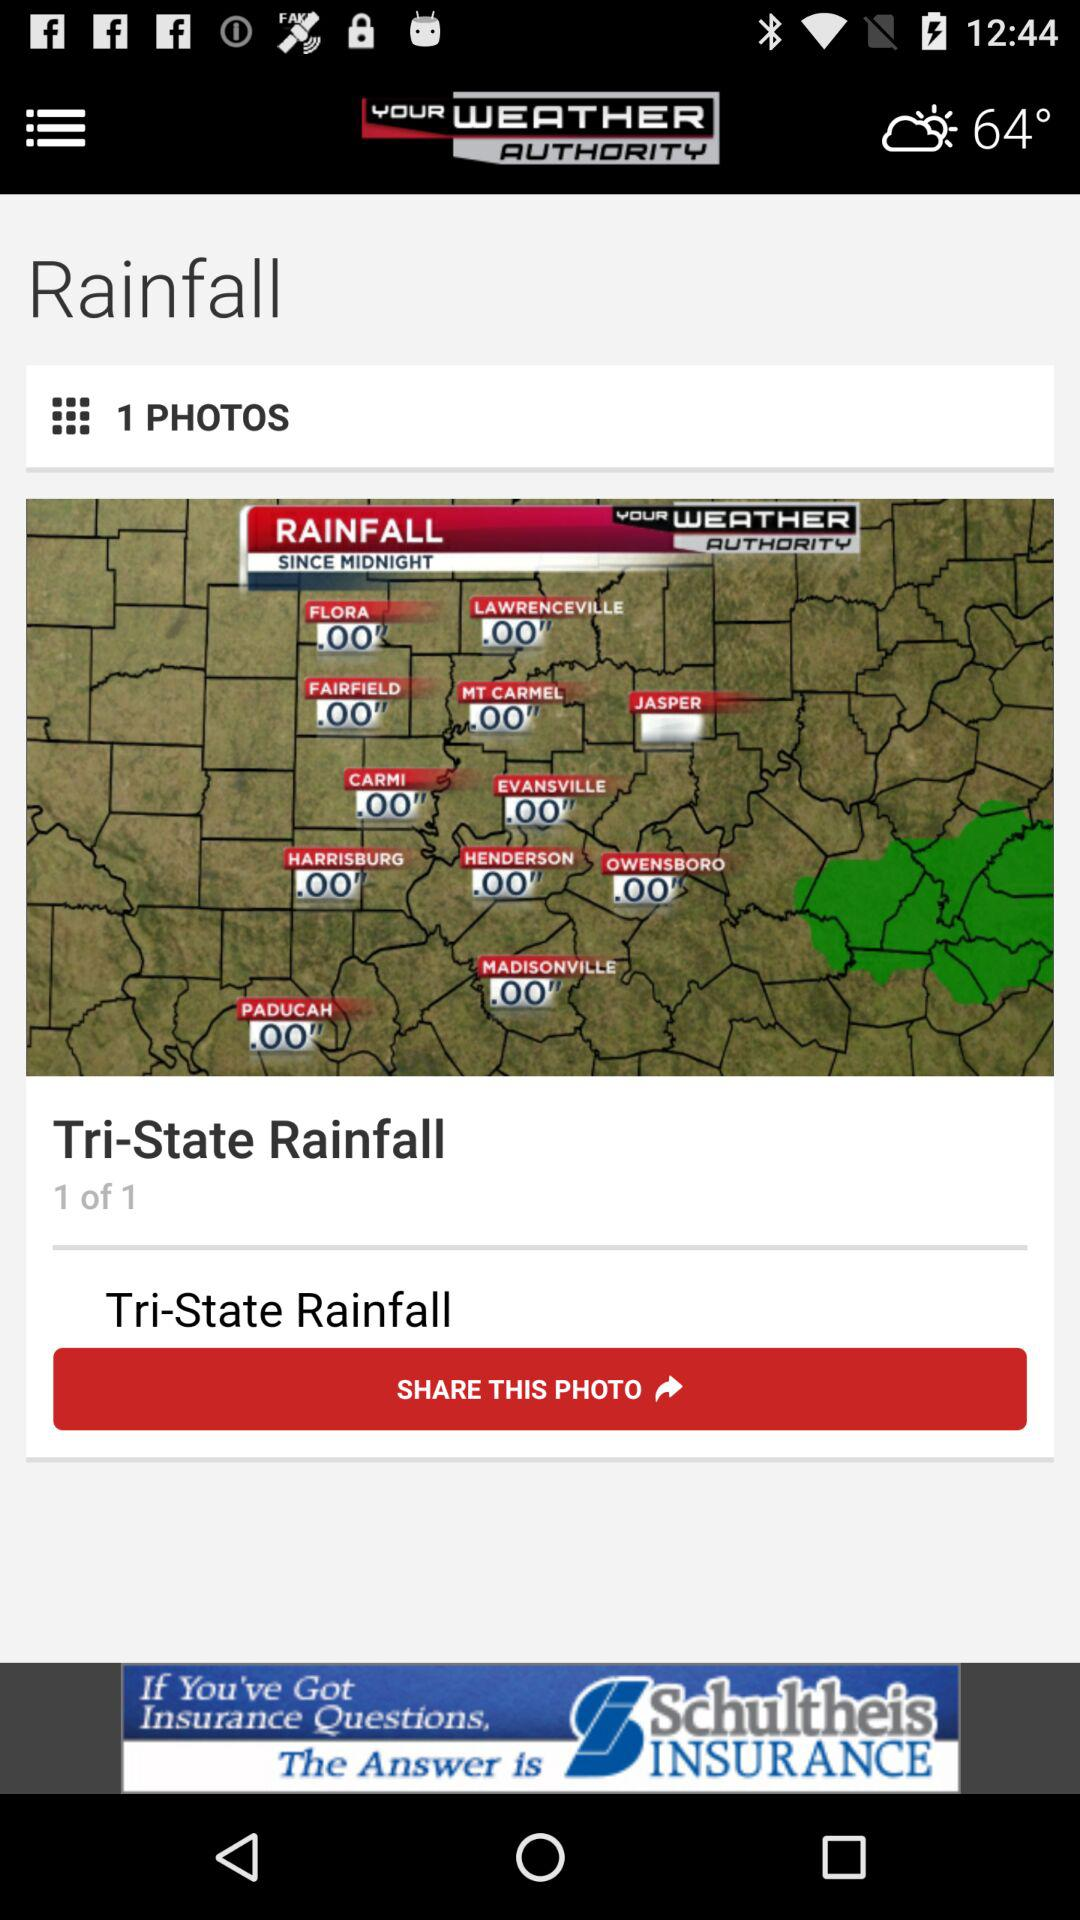How many photos are in the album?
Answer the question using a single word or phrase. 1 